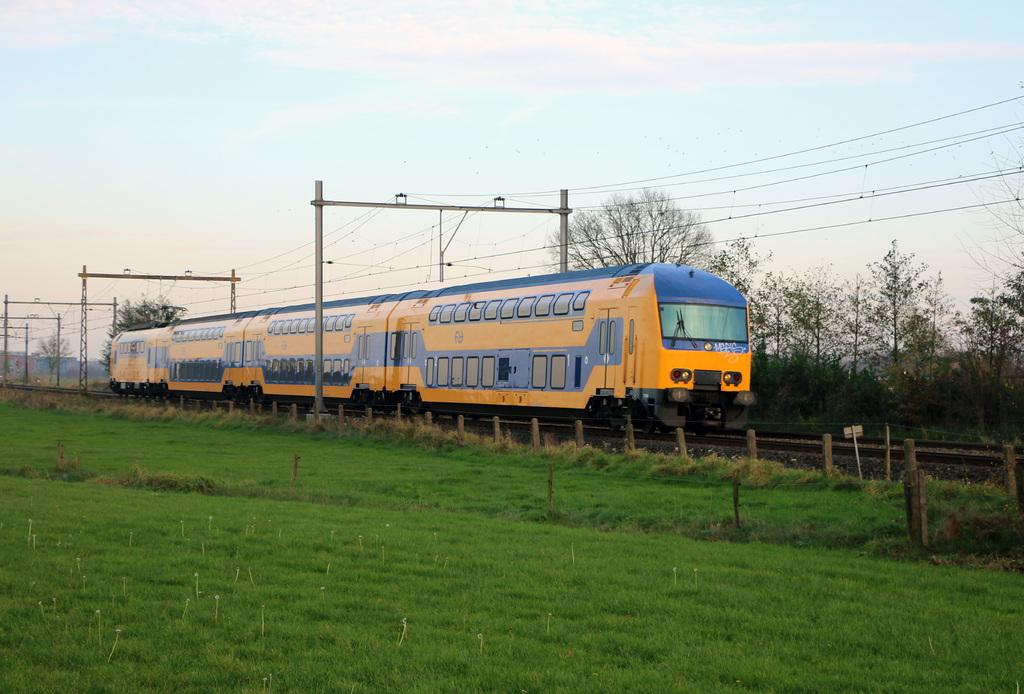What type of vehicle is on the track in the image? There is a locomotive on the track in the image. What type of natural elements can be seen in the image? Stones, grass, trees, and clouds are present in the image. What type of man-made structures can be seen in the image? Barrier poles, electric poles, and electric cables are present in the image. What is visible in the background of the image? The sky is visible in the background of the image. What type of apparel is the locomotive wearing in the image? Locomotives do not wear apparel; they are machines. 